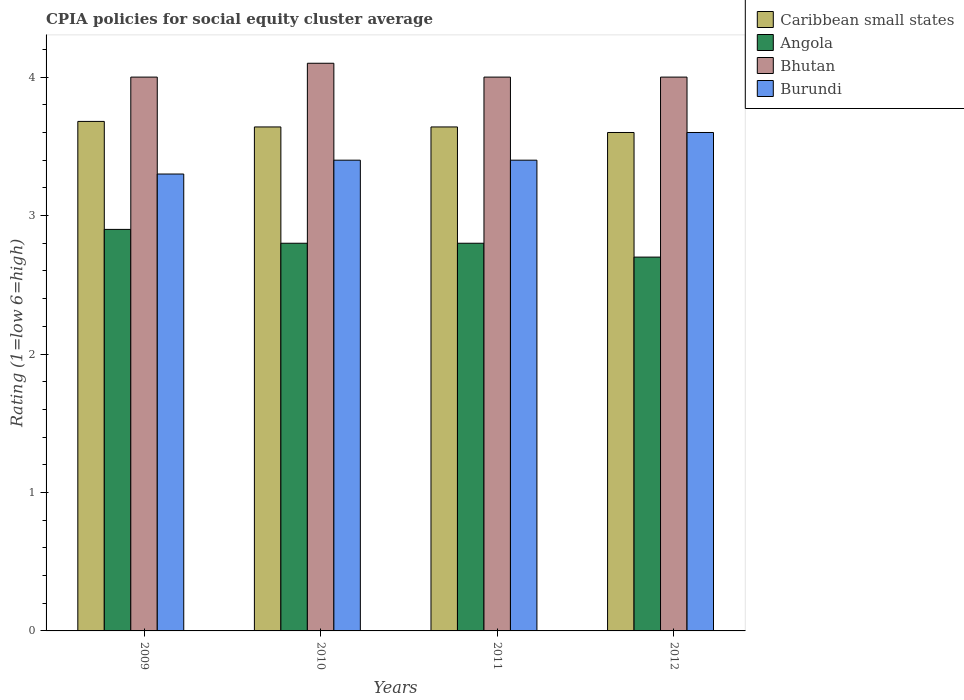How many different coloured bars are there?
Ensure brevity in your answer.  4. How many groups of bars are there?
Offer a very short reply. 4. How many bars are there on the 2nd tick from the left?
Give a very brief answer. 4. What is the label of the 2nd group of bars from the left?
Keep it short and to the point. 2010. In how many cases, is the number of bars for a given year not equal to the number of legend labels?
Your answer should be very brief. 0. What is the CPIA rating in Bhutan in 2009?
Keep it short and to the point. 4. Across all years, what is the maximum CPIA rating in Angola?
Offer a very short reply. 2.9. Across all years, what is the minimum CPIA rating in Caribbean small states?
Provide a succinct answer. 3.6. In which year was the CPIA rating in Angola minimum?
Your response must be concise. 2012. What is the difference between the CPIA rating in Caribbean small states in 2011 and that in 2012?
Offer a very short reply. 0.04. What is the difference between the CPIA rating in Caribbean small states in 2011 and the CPIA rating in Angola in 2010?
Your answer should be very brief. 0.84. What is the average CPIA rating in Angola per year?
Keep it short and to the point. 2.8. What is the ratio of the CPIA rating in Burundi in 2009 to that in 2011?
Provide a succinct answer. 0.97. Is the CPIA rating in Bhutan in 2009 less than that in 2012?
Ensure brevity in your answer.  No. What is the difference between the highest and the second highest CPIA rating in Angola?
Keep it short and to the point. 0.1. What is the difference between the highest and the lowest CPIA rating in Angola?
Make the answer very short. 0.2. In how many years, is the CPIA rating in Angola greater than the average CPIA rating in Angola taken over all years?
Keep it short and to the point. 1. Is the sum of the CPIA rating in Burundi in 2011 and 2012 greater than the maximum CPIA rating in Bhutan across all years?
Your response must be concise. Yes. Is it the case that in every year, the sum of the CPIA rating in Bhutan and CPIA rating in Caribbean small states is greater than the sum of CPIA rating in Angola and CPIA rating in Burundi?
Provide a succinct answer. No. What does the 4th bar from the left in 2012 represents?
Make the answer very short. Burundi. What does the 1st bar from the right in 2010 represents?
Give a very brief answer. Burundi. Is it the case that in every year, the sum of the CPIA rating in Burundi and CPIA rating in Bhutan is greater than the CPIA rating in Angola?
Ensure brevity in your answer.  Yes. What is the difference between two consecutive major ticks on the Y-axis?
Your answer should be compact. 1. Does the graph contain any zero values?
Provide a short and direct response. No. Where does the legend appear in the graph?
Your response must be concise. Top right. How many legend labels are there?
Keep it short and to the point. 4. What is the title of the graph?
Provide a succinct answer. CPIA policies for social equity cluster average. What is the Rating (1=low 6=high) in Caribbean small states in 2009?
Offer a very short reply. 3.68. What is the Rating (1=low 6=high) in Angola in 2009?
Ensure brevity in your answer.  2.9. What is the Rating (1=low 6=high) of Bhutan in 2009?
Offer a very short reply. 4. What is the Rating (1=low 6=high) in Burundi in 2009?
Provide a succinct answer. 3.3. What is the Rating (1=low 6=high) of Caribbean small states in 2010?
Offer a very short reply. 3.64. What is the Rating (1=low 6=high) in Angola in 2010?
Offer a terse response. 2.8. What is the Rating (1=low 6=high) of Bhutan in 2010?
Provide a succinct answer. 4.1. What is the Rating (1=low 6=high) in Caribbean small states in 2011?
Offer a very short reply. 3.64. What is the Rating (1=low 6=high) of Angola in 2011?
Offer a very short reply. 2.8. What is the Rating (1=low 6=high) in Burundi in 2011?
Ensure brevity in your answer.  3.4. What is the Rating (1=low 6=high) in Caribbean small states in 2012?
Provide a succinct answer. 3.6. Across all years, what is the maximum Rating (1=low 6=high) in Caribbean small states?
Offer a terse response. 3.68. Across all years, what is the minimum Rating (1=low 6=high) of Caribbean small states?
Offer a very short reply. 3.6. What is the total Rating (1=low 6=high) in Caribbean small states in the graph?
Your response must be concise. 14.56. What is the total Rating (1=low 6=high) in Angola in the graph?
Your response must be concise. 11.2. What is the total Rating (1=low 6=high) in Bhutan in the graph?
Give a very brief answer. 16.1. What is the total Rating (1=low 6=high) of Burundi in the graph?
Keep it short and to the point. 13.7. What is the difference between the Rating (1=low 6=high) of Caribbean small states in 2009 and that in 2010?
Make the answer very short. 0.04. What is the difference between the Rating (1=low 6=high) in Angola in 2009 and that in 2010?
Make the answer very short. 0.1. What is the difference between the Rating (1=low 6=high) of Bhutan in 2009 and that in 2010?
Give a very brief answer. -0.1. What is the difference between the Rating (1=low 6=high) of Burundi in 2009 and that in 2010?
Your answer should be compact. -0.1. What is the difference between the Rating (1=low 6=high) of Angola in 2009 and that in 2011?
Offer a very short reply. 0.1. What is the difference between the Rating (1=low 6=high) in Bhutan in 2009 and that in 2011?
Your answer should be compact. 0. What is the difference between the Rating (1=low 6=high) in Caribbean small states in 2009 and that in 2012?
Provide a succinct answer. 0.08. What is the difference between the Rating (1=low 6=high) in Angola in 2009 and that in 2012?
Your answer should be very brief. 0.2. What is the difference between the Rating (1=low 6=high) in Bhutan in 2009 and that in 2012?
Make the answer very short. 0. What is the difference between the Rating (1=low 6=high) in Angola in 2010 and that in 2011?
Your answer should be compact. 0. What is the difference between the Rating (1=low 6=high) of Caribbean small states in 2010 and that in 2012?
Your answer should be very brief. 0.04. What is the difference between the Rating (1=low 6=high) of Caribbean small states in 2011 and that in 2012?
Make the answer very short. 0.04. What is the difference between the Rating (1=low 6=high) of Bhutan in 2011 and that in 2012?
Provide a short and direct response. 0. What is the difference between the Rating (1=low 6=high) of Caribbean small states in 2009 and the Rating (1=low 6=high) of Bhutan in 2010?
Your answer should be compact. -0.42. What is the difference between the Rating (1=low 6=high) of Caribbean small states in 2009 and the Rating (1=low 6=high) of Burundi in 2010?
Make the answer very short. 0.28. What is the difference between the Rating (1=low 6=high) in Caribbean small states in 2009 and the Rating (1=low 6=high) in Bhutan in 2011?
Provide a succinct answer. -0.32. What is the difference between the Rating (1=low 6=high) in Caribbean small states in 2009 and the Rating (1=low 6=high) in Burundi in 2011?
Offer a terse response. 0.28. What is the difference between the Rating (1=low 6=high) of Angola in 2009 and the Rating (1=low 6=high) of Burundi in 2011?
Your response must be concise. -0.5. What is the difference between the Rating (1=low 6=high) of Bhutan in 2009 and the Rating (1=low 6=high) of Burundi in 2011?
Provide a succinct answer. 0.6. What is the difference between the Rating (1=low 6=high) in Caribbean small states in 2009 and the Rating (1=low 6=high) in Bhutan in 2012?
Offer a terse response. -0.32. What is the difference between the Rating (1=low 6=high) of Caribbean small states in 2009 and the Rating (1=low 6=high) of Burundi in 2012?
Your answer should be compact. 0.08. What is the difference between the Rating (1=low 6=high) of Caribbean small states in 2010 and the Rating (1=low 6=high) of Angola in 2011?
Offer a terse response. 0.84. What is the difference between the Rating (1=low 6=high) in Caribbean small states in 2010 and the Rating (1=low 6=high) in Bhutan in 2011?
Make the answer very short. -0.36. What is the difference between the Rating (1=low 6=high) in Caribbean small states in 2010 and the Rating (1=low 6=high) in Burundi in 2011?
Give a very brief answer. 0.24. What is the difference between the Rating (1=low 6=high) of Angola in 2010 and the Rating (1=low 6=high) of Burundi in 2011?
Keep it short and to the point. -0.6. What is the difference between the Rating (1=low 6=high) of Bhutan in 2010 and the Rating (1=low 6=high) of Burundi in 2011?
Your answer should be compact. 0.7. What is the difference between the Rating (1=low 6=high) in Caribbean small states in 2010 and the Rating (1=low 6=high) in Bhutan in 2012?
Your answer should be compact. -0.36. What is the difference between the Rating (1=low 6=high) in Caribbean small states in 2011 and the Rating (1=low 6=high) in Angola in 2012?
Provide a short and direct response. 0.94. What is the difference between the Rating (1=low 6=high) of Caribbean small states in 2011 and the Rating (1=low 6=high) of Bhutan in 2012?
Your answer should be compact. -0.36. What is the difference between the Rating (1=low 6=high) of Caribbean small states in 2011 and the Rating (1=low 6=high) of Burundi in 2012?
Give a very brief answer. 0.04. What is the difference between the Rating (1=low 6=high) of Angola in 2011 and the Rating (1=low 6=high) of Burundi in 2012?
Offer a terse response. -0.8. What is the average Rating (1=low 6=high) of Caribbean small states per year?
Provide a short and direct response. 3.64. What is the average Rating (1=low 6=high) in Bhutan per year?
Make the answer very short. 4.03. What is the average Rating (1=low 6=high) of Burundi per year?
Offer a very short reply. 3.42. In the year 2009, what is the difference between the Rating (1=low 6=high) of Caribbean small states and Rating (1=low 6=high) of Angola?
Give a very brief answer. 0.78. In the year 2009, what is the difference between the Rating (1=low 6=high) in Caribbean small states and Rating (1=low 6=high) in Bhutan?
Your answer should be very brief. -0.32. In the year 2009, what is the difference between the Rating (1=low 6=high) of Caribbean small states and Rating (1=low 6=high) of Burundi?
Make the answer very short. 0.38. In the year 2009, what is the difference between the Rating (1=low 6=high) of Angola and Rating (1=low 6=high) of Bhutan?
Offer a very short reply. -1.1. In the year 2010, what is the difference between the Rating (1=low 6=high) in Caribbean small states and Rating (1=low 6=high) in Angola?
Provide a succinct answer. 0.84. In the year 2010, what is the difference between the Rating (1=low 6=high) in Caribbean small states and Rating (1=low 6=high) in Bhutan?
Offer a very short reply. -0.46. In the year 2010, what is the difference between the Rating (1=low 6=high) of Caribbean small states and Rating (1=low 6=high) of Burundi?
Keep it short and to the point. 0.24. In the year 2010, what is the difference between the Rating (1=low 6=high) of Angola and Rating (1=low 6=high) of Bhutan?
Your answer should be compact. -1.3. In the year 2011, what is the difference between the Rating (1=low 6=high) in Caribbean small states and Rating (1=low 6=high) in Angola?
Keep it short and to the point. 0.84. In the year 2011, what is the difference between the Rating (1=low 6=high) of Caribbean small states and Rating (1=low 6=high) of Bhutan?
Provide a succinct answer. -0.36. In the year 2011, what is the difference between the Rating (1=low 6=high) of Caribbean small states and Rating (1=low 6=high) of Burundi?
Keep it short and to the point. 0.24. In the year 2011, what is the difference between the Rating (1=low 6=high) in Bhutan and Rating (1=low 6=high) in Burundi?
Provide a succinct answer. 0.6. In the year 2012, what is the difference between the Rating (1=low 6=high) in Caribbean small states and Rating (1=low 6=high) in Bhutan?
Keep it short and to the point. -0.4. In the year 2012, what is the difference between the Rating (1=low 6=high) in Caribbean small states and Rating (1=low 6=high) in Burundi?
Ensure brevity in your answer.  0. In the year 2012, what is the difference between the Rating (1=low 6=high) of Bhutan and Rating (1=low 6=high) of Burundi?
Your response must be concise. 0.4. What is the ratio of the Rating (1=low 6=high) in Caribbean small states in 2009 to that in 2010?
Offer a terse response. 1.01. What is the ratio of the Rating (1=low 6=high) of Angola in 2009 to that in 2010?
Give a very brief answer. 1.04. What is the ratio of the Rating (1=low 6=high) of Bhutan in 2009 to that in 2010?
Give a very brief answer. 0.98. What is the ratio of the Rating (1=low 6=high) of Burundi in 2009 to that in 2010?
Your answer should be very brief. 0.97. What is the ratio of the Rating (1=low 6=high) in Caribbean small states in 2009 to that in 2011?
Give a very brief answer. 1.01. What is the ratio of the Rating (1=low 6=high) in Angola in 2009 to that in 2011?
Provide a succinct answer. 1.04. What is the ratio of the Rating (1=low 6=high) of Bhutan in 2009 to that in 2011?
Offer a very short reply. 1. What is the ratio of the Rating (1=low 6=high) in Burundi in 2009 to that in 2011?
Provide a short and direct response. 0.97. What is the ratio of the Rating (1=low 6=high) in Caribbean small states in 2009 to that in 2012?
Give a very brief answer. 1.02. What is the ratio of the Rating (1=low 6=high) in Angola in 2009 to that in 2012?
Your response must be concise. 1.07. What is the ratio of the Rating (1=low 6=high) of Angola in 2010 to that in 2011?
Ensure brevity in your answer.  1. What is the ratio of the Rating (1=low 6=high) in Burundi in 2010 to that in 2011?
Provide a succinct answer. 1. What is the ratio of the Rating (1=low 6=high) in Caribbean small states in 2010 to that in 2012?
Provide a short and direct response. 1.01. What is the ratio of the Rating (1=low 6=high) in Burundi in 2010 to that in 2012?
Give a very brief answer. 0.94. What is the ratio of the Rating (1=low 6=high) of Caribbean small states in 2011 to that in 2012?
Offer a very short reply. 1.01. What is the ratio of the Rating (1=low 6=high) of Angola in 2011 to that in 2012?
Offer a terse response. 1.04. What is the difference between the highest and the second highest Rating (1=low 6=high) in Caribbean small states?
Ensure brevity in your answer.  0.04. What is the difference between the highest and the second highest Rating (1=low 6=high) in Angola?
Offer a very short reply. 0.1. What is the difference between the highest and the second highest Rating (1=low 6=high) of Burundi?
Keep it short and to the point. 0.2. What is the difference between the highest and the lowest Rating (1=low 6=high) of Angola?
Keep it short and to the point. 0.2. What is the difference between the highest and the lowest Rating (1=low 6=high) in Bhutan?
Ensure brevity in your answer.  0.1. What is the difference between the highest and the lowest Rating (1=low 6=high) of Burundi?
Provide a short and direct response. 0.3. 